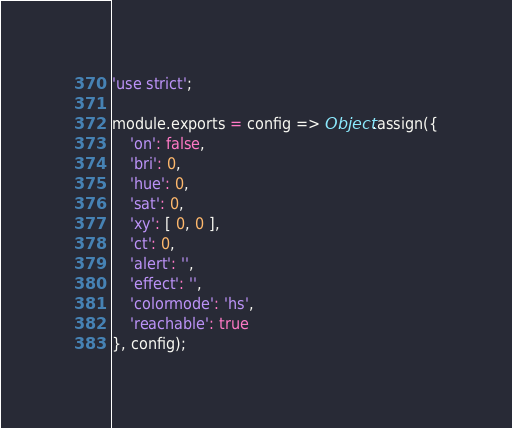Convert code to text. <code><loc_0><loc_0><loc_500><loc_500><_JavaScript_>'use strict';

module.exports = config => Object.assign({
	'on': false,
	'bri': 0,
	'hue': 0,
	'sat': 0,
	'xy': [ 0, 0 ],
	'ct': 0,
	'alert': '',
	'effect': '',
	'colormode': 'hs',
	'reachable': true
}, config);</code> 